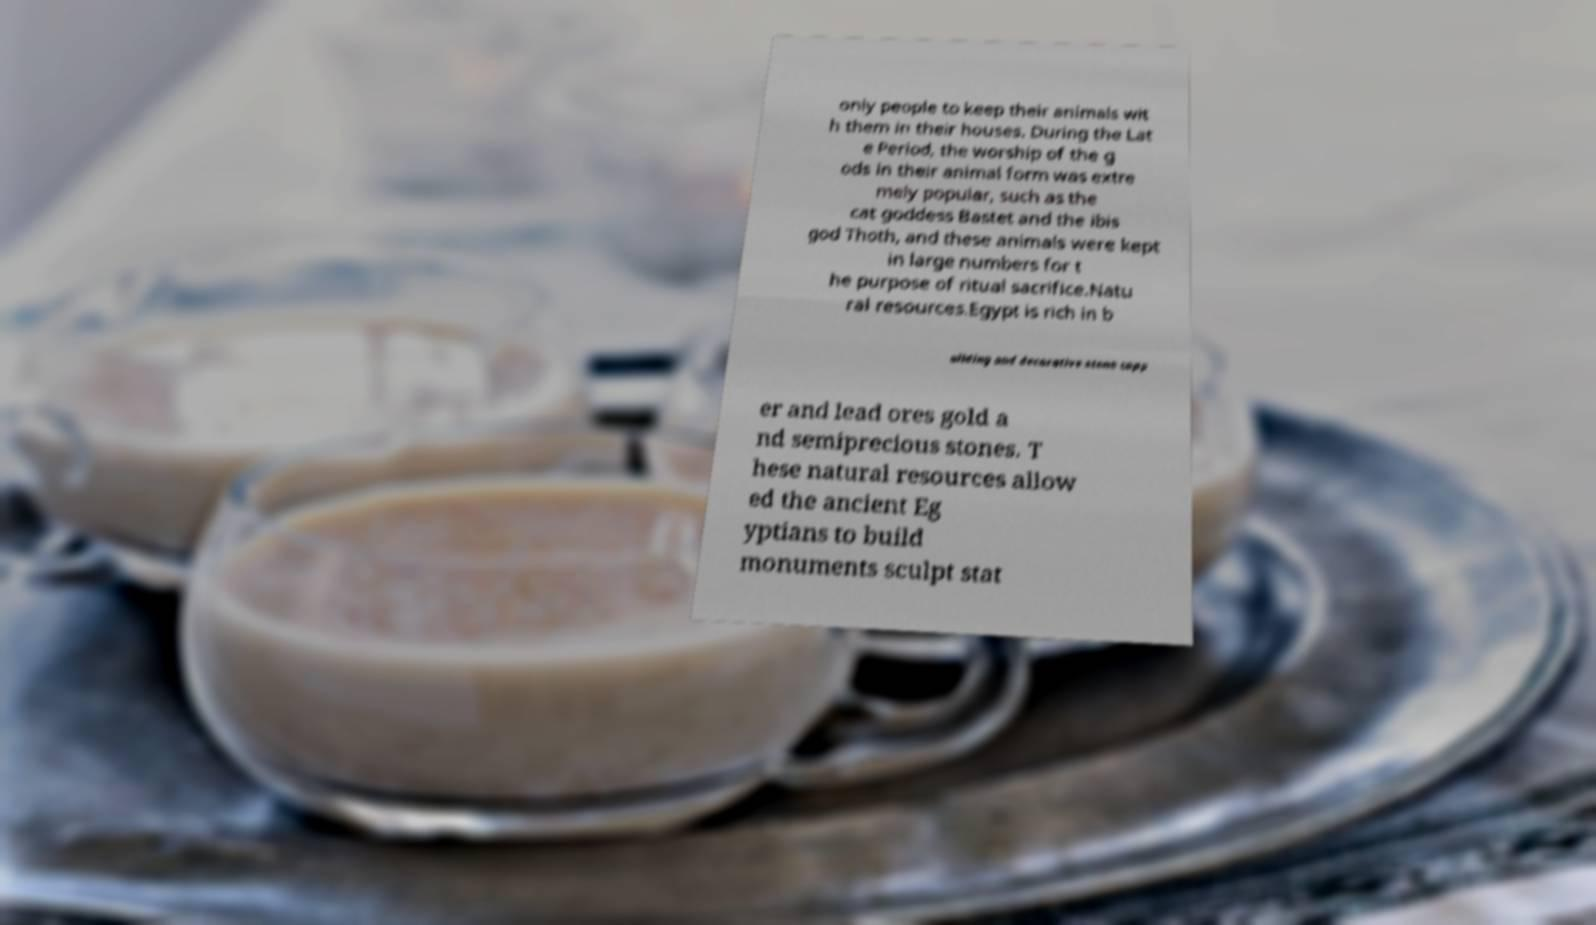Could you assist in decoding the text presented in this image and type it out clearly? only people to keep their animals wit h them in their houses. During the Lat e Period, the worship of the g ods in their animal form was extre mely popular, such as the cat goddess Bastet and the ibis god Thoth, and these animals were kept in large numbers for t he purpose of ritual sacrifice.Natu ral resources.Egypt is rich in b uilding and decorative stone copp er and lead ores gold a nd semiprecious stones. T hese natural resources allow ed the ancient Eg yptians to build monuments sculpt stat 